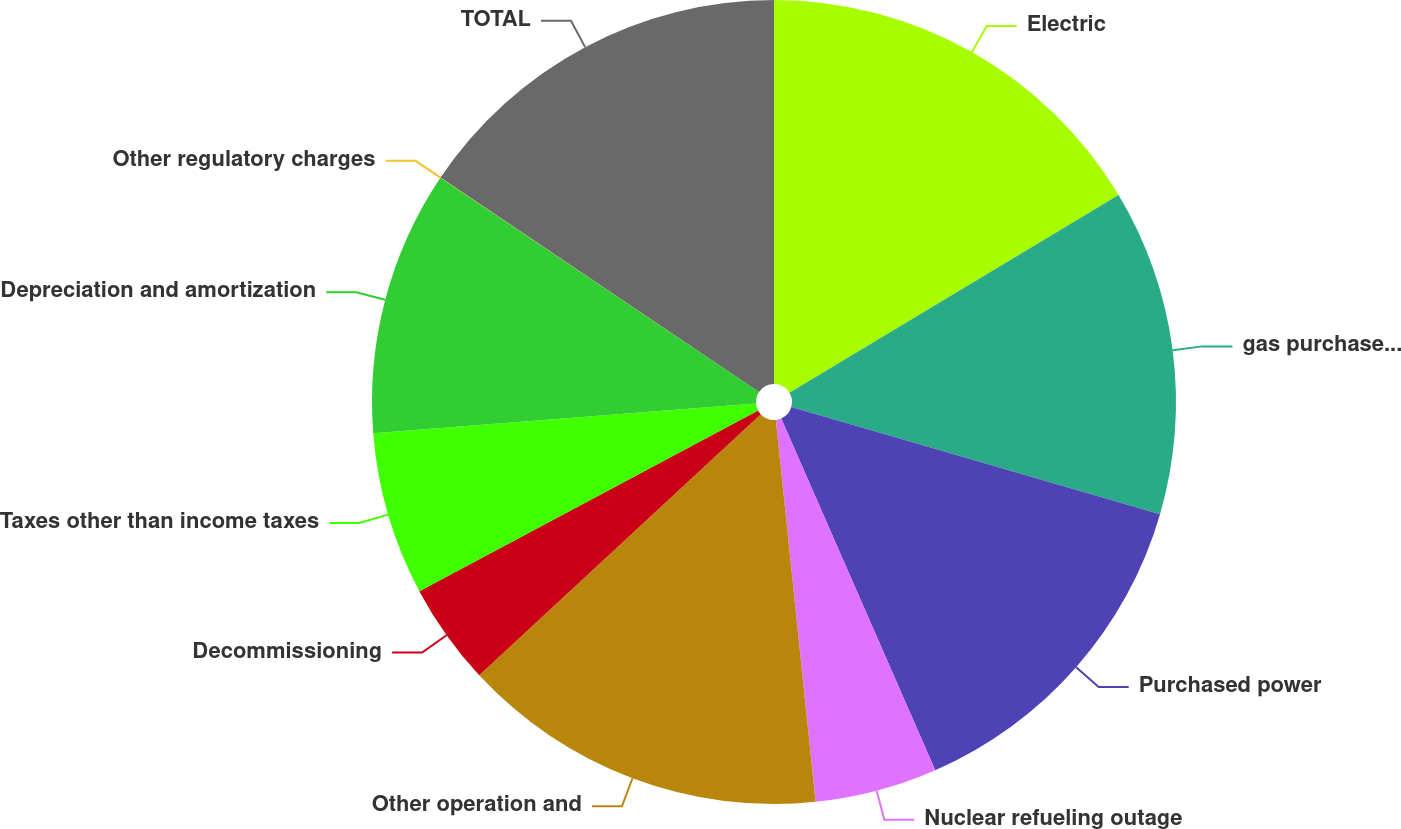<chart> <loc_0><loc_0><loc_500><loc_500><pie_chart><fcel>Electric<fcel>gas purchased for resale<fcel>Purchased power<fcel>Nuclear refueling outage<fcel>Other operation and<fcel>Decommissioning<fcel>Taxes other than income taxes<fcel>Depreciation and amortization<fcel>Other regulatory charges<fcel>TOTAL<nl><fcel>16.39%<fcel>13.11%<fcel>13.93%<fcel>4.92%<fcel>14.75%<fcel>4.1%<fcel>6.56%<fcel>10.66%<fcel>0.01%<fcel>15.57%<nl></chart> 